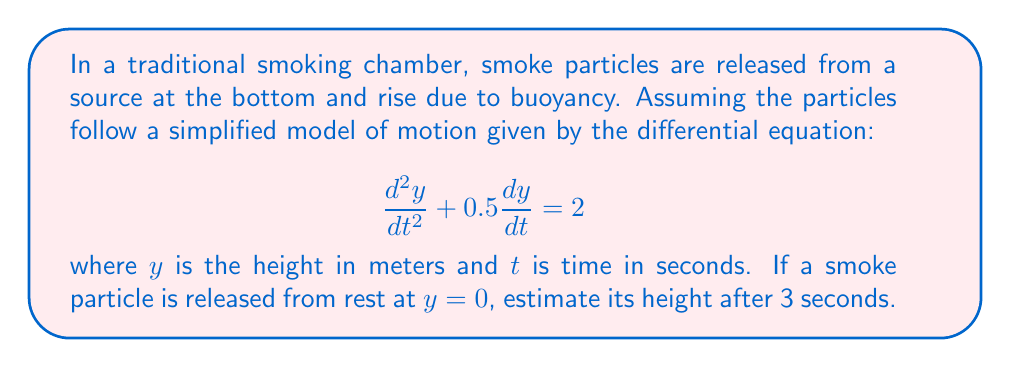Show me your answer to this math problem. To solve this problem, we'll follow these steps:

1) First, we need to solve the given differential equation. It's a second-order linear differential equation with constant coefficients.

2) The general solution for this type of equation is:

   $$y(t) = y_h(t) + y_p(t)$$

   where $y_h(t)$ is the homogeneous solution and $y_p(t)$ is the particular solution.

3) The homogeneous equation is:

   $$\frac{d^2y}{dt^2} + 0.5\frac{dy}{dt} = 0$$

   Its characteristic equation is:

   $$r^2 + 0.5r = 0$$
   $$r(r + 0.5) = 0$$

   So, $r = 0$ or $r = -0.5$

   Therefore, the homogeneous solution is:

   $$y_h(t) = C_1 + C_2e^{-0.5t}$$

4) For the particular solution, we can guess a constant:

   $$y_p(t) = A$$

   Substituting this into the original equation:

   $$0 + 0 = 2$$
   $$A = 4$$

5) So, the general solution is:

   $$y(t) = C_1 + C_2e^{-0.5t} + 4$$

6) Now we use the initial conditions. At $t=0$, $y=0$ and $\frac{dy}{dt}=0$:

   $$0 = C_1 + C_2 + 4$$
   $$0 = -0.5C_2$$

   From the second equation, $C_2 = 0$. From the first, $C_1 = -4$.

7) Therefore, the particular solution for our problem is:

   $$y(t) = 4(1 - e^{-0.5t})$$

8) To find the height at $t=3$, we substitute:

   $$y(3) = 4(1 - e^{-0.5(3)}) \approx 3.51$$

Therefore, after 3 seconds, the smoke particle will be approximately 3.51 meters high.
Answer: 3.51 meters 